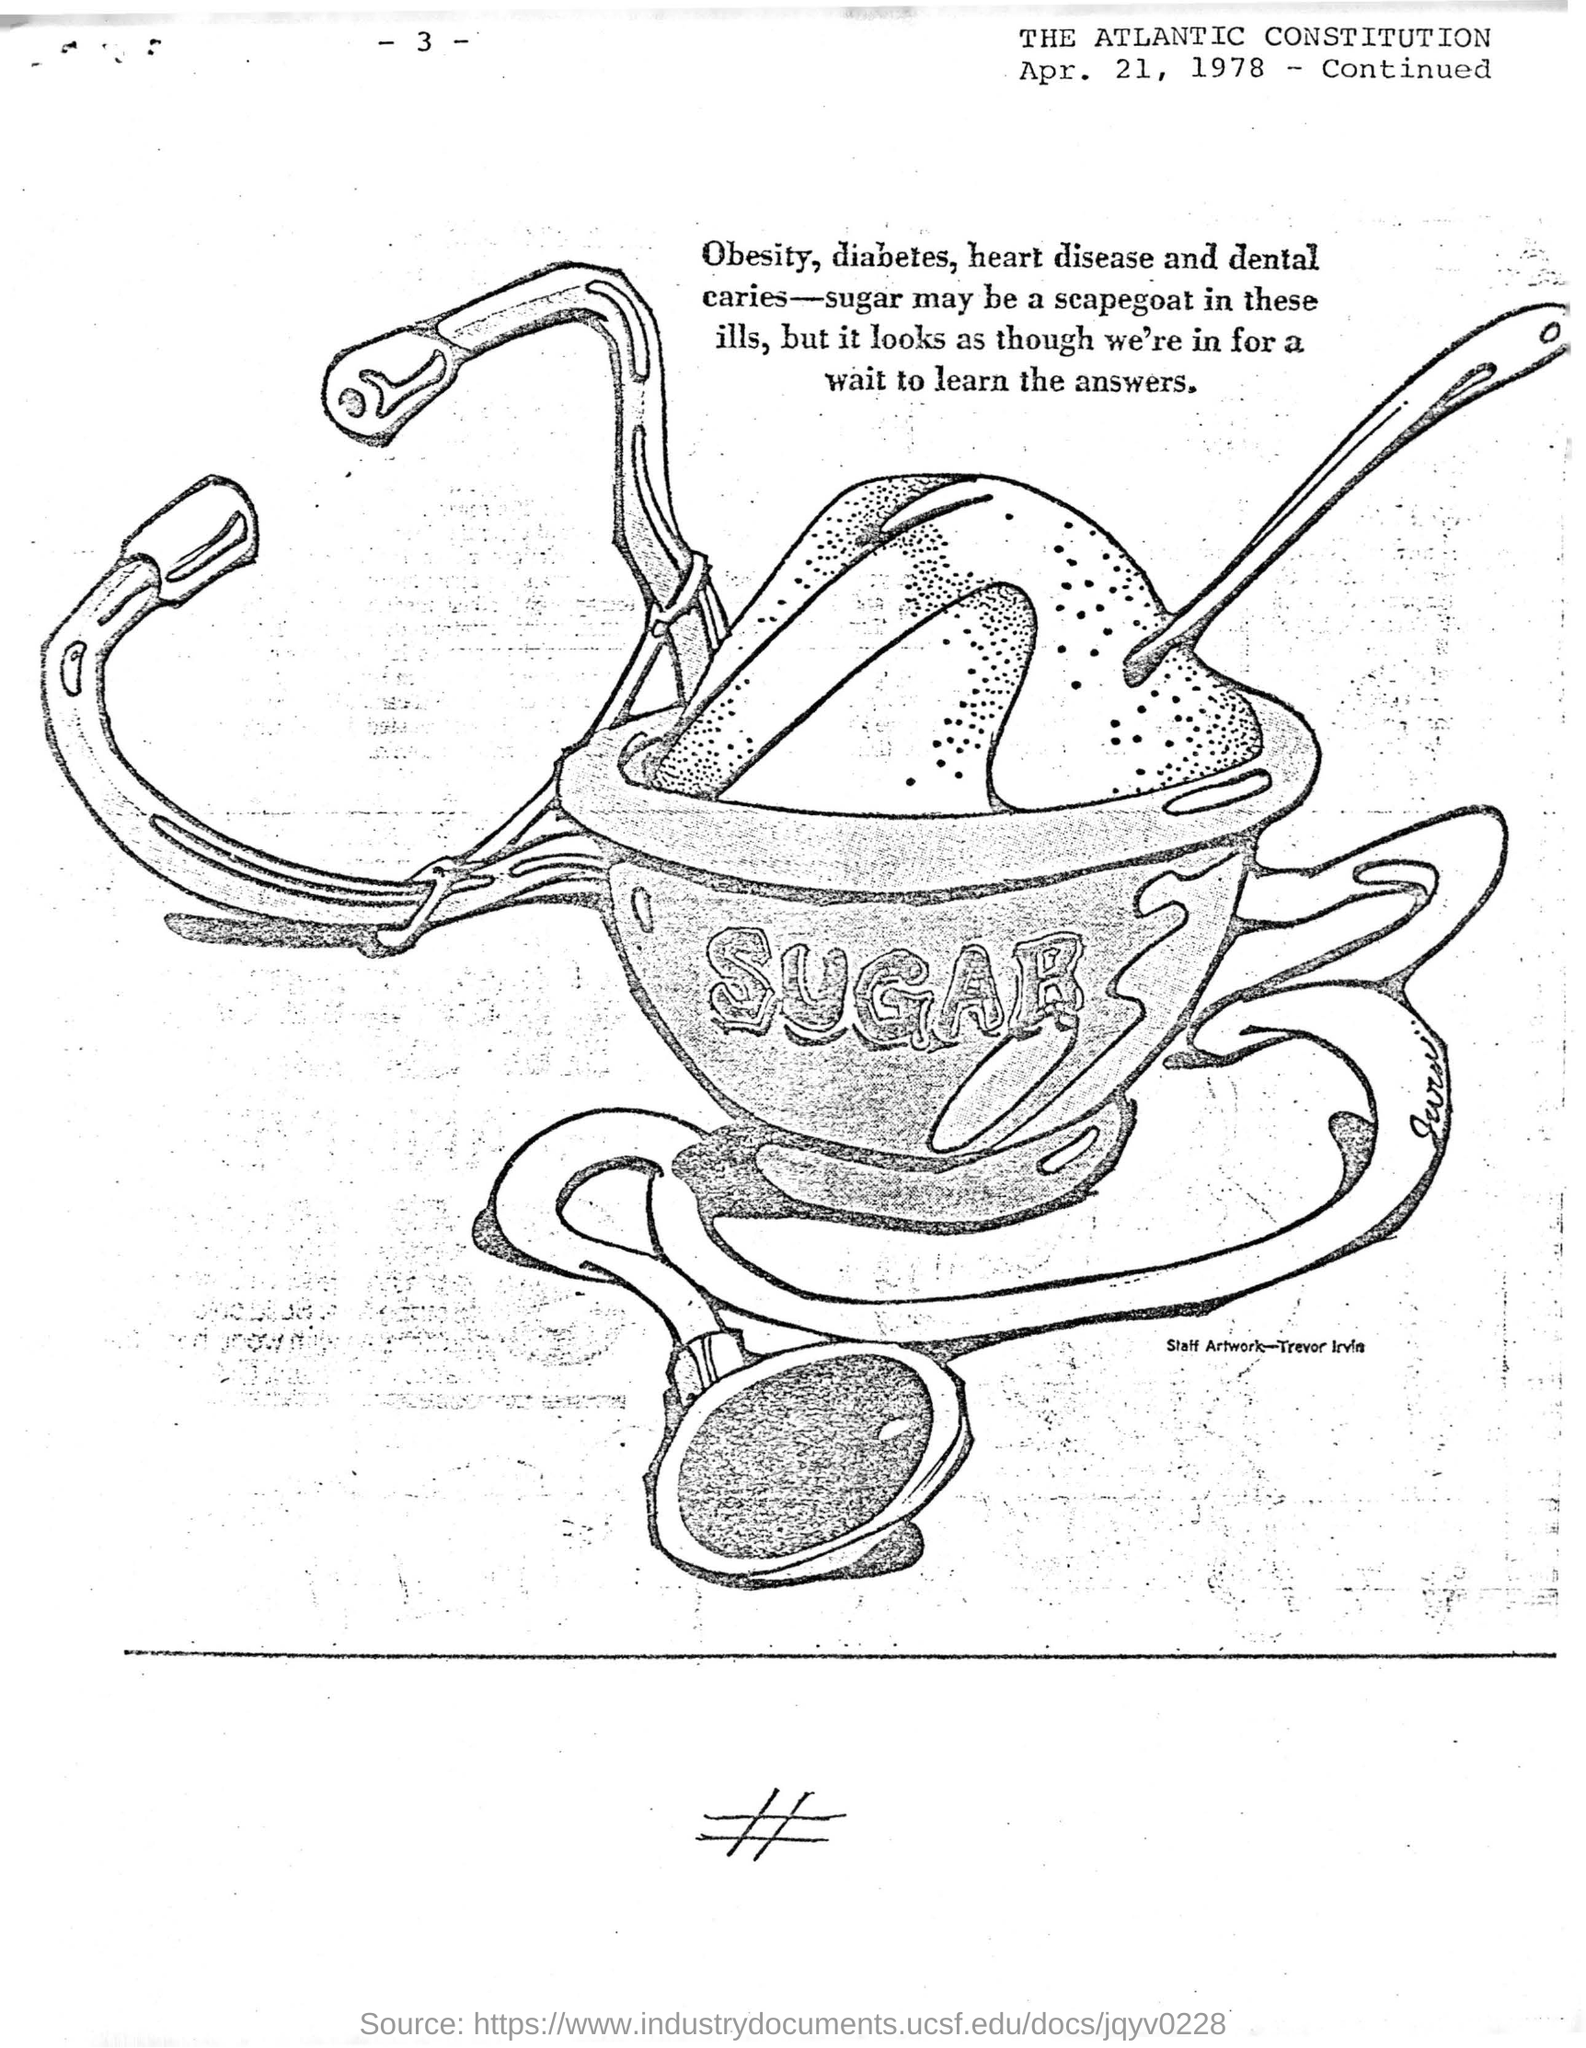Identify some key points in this picture. The date mentioned is April 21, 1978. The Constitution's name is the Atlantic Constitution. Sugar has been unfairly blamed for a variety of health problems, including obesity, diabetes, heart disease, and dental caries. 